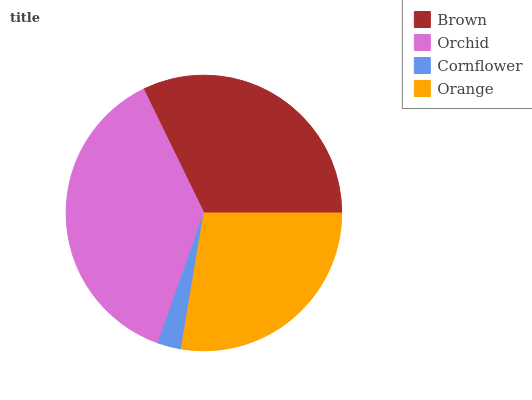Is Cornflower the minimum?
Answer yes or no. Yes. Is Orchid the maximum?
Answer yes or no. Yes. Is Orchid the minimum?
Answer yes or no. No. Is Cornflower the maximum?
Answer yes or no. No. Is Orchid greater than Cornflower?
Answer yes or no. Yes. Is Cornflower less than Orchid?
Answer yes or no. Yes. Is Cornflower greater than Orchid?
Answer yes or no. No. Is Orchid less than Cornflower?
Answer yes or no. No. Is Brown the high median?
Answer yes or no. Yes. Is Orange the low median?
Answer yes or no. Yes. Is Orange the high median?
Answer yes or no. No. Is Brown the low median?
Answer yes or no. No. 